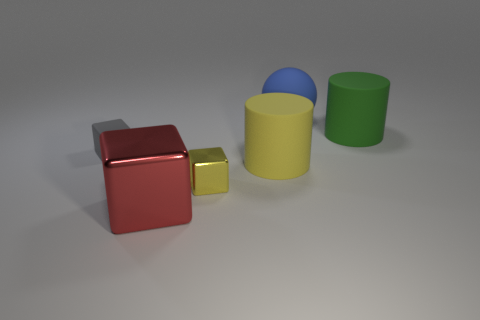There is a blue object; does it have the same size as the gray matte block left of the red shiny block?
Offer a terse response. No. Is there a cylinder of the same color as the tiny metal thing?
Offer a terse response. Yes. Do the green thing and the large cube have the same material?
Provide a short and direct response. No. There is a large blue matte sphere; how many big yellow rubber objects are right of it?
Offer a terse response. 0. There is a big thing that is both in front of the green rubber object and right of the red cube; what material is it?
Make the answer very short. Rubber. How many brown shiny spheres are the same size as the red metallic thing?
Keep it short and to the point. 0. The large thing that is in front of the cylinder that is in front of the tiny rubber cube is what color?
Ensure brevity in your answer.  Red. Are there any big purple cylinders?
Make the answer very short. No. Is the tiny rubber object the same shape as the blue matte thing?
Provide a succinct answer. No. There is a rubber cylinder behind the tiny matte block; how many yellow matte cylinders are in front of it?
Provide a succinct answer. 1. 